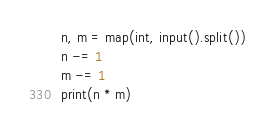<code> <loc_0><loc_0><loc_500><loc_500><_Python_>n, m = map(int, input().split())
n -= 1
m -= 1
print(n * m)
</code> 